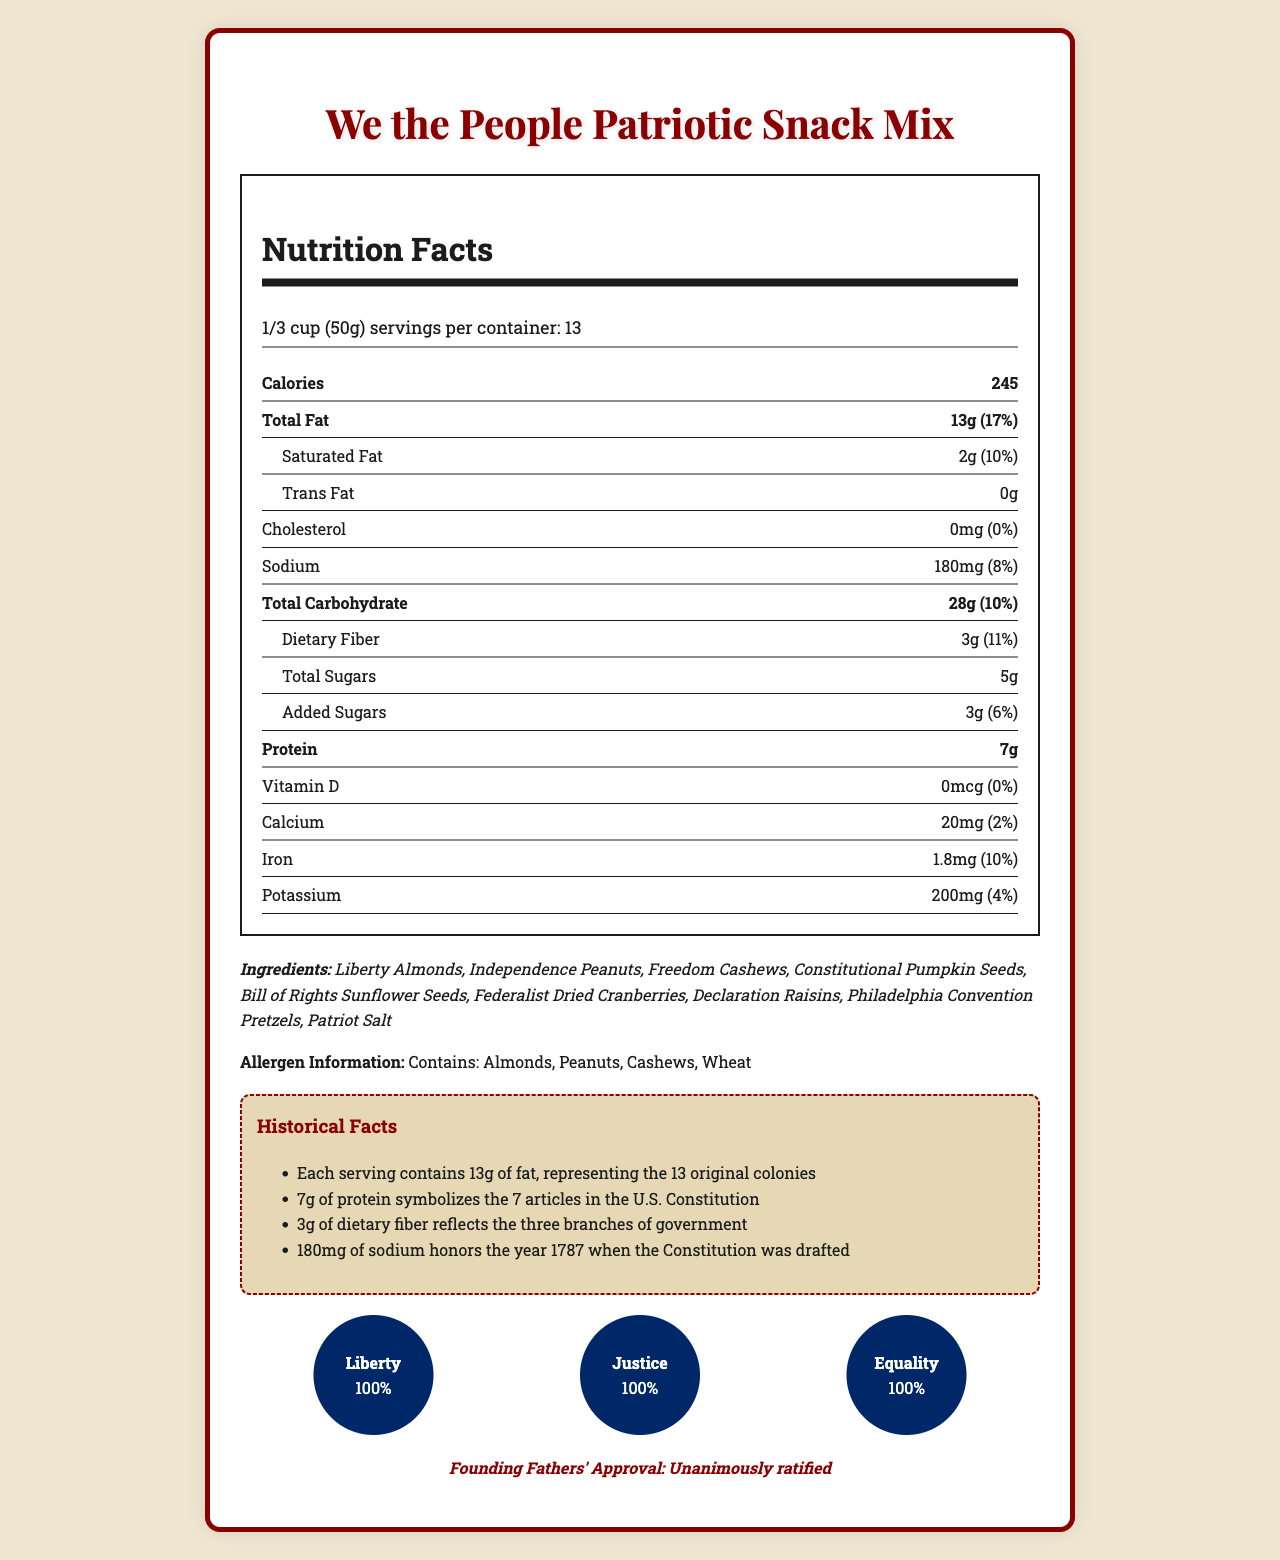what is the serving size? The serving size is explicitly mentioned near the top of the nutrition facts label.
Answer: 1/3 cup (50g) how many calories are in one serving? The label lists 245 calories per serving.
Answer: 245 what percentage of the daily value of total fat does one serving contain? The total fat amount is given as 13g and 17% of the daily value.
Answer: 17% how much protein is in one serving? The protein content per serving is listed as 7g.
Answer: 7g what is the allergen information for the snack mix? The allergen information is provided at the bottom of the label.
Answer: Contains: Almonds, Peanuts, Cashews, Wheat how many servings are in the container? The servings per container are listed as 13.
Answer: 13 how much dietary fiber is in one serving? The dietary fiber content per serving is given as 3g.
Answer: 3g how much cholesterol is in the snack mix? The label states that the cholesterol content is 0mg.
Answer: 0mg how many grams of added sugars does one serving have? The added sugars content per serving is listed as 3g.
Answer: 3g who approved the snack mix? A. Congress B. Founding Fathers C. Constitutional Convention D. Supreme Court According to the document, the snack mix is "Unanimously ratified" by the Founding Fathers.
Answer: B. Founding Fathers what is represented by 7g of protein? A. 7 Presidents B. 7 Articles C. 7 States D. 7 Amendments The document mentions that 7g of protein symbolizes the 7 articles in the U.S. Constitution.
Answer: B. 7 Articles does the snack mix contain any trans fat? The document states there are 0g of trans fat.
Answer: No summarize the main idea of the document. The nutrition facts label is designed to not only inform about the nutritional value of the snack but also to draw connections to American historical and patriotic themes, illustrated through symbolic elements and historical facts.
Answer: The document provides a nutrition facts label for the "We the People Patriotic Snack Mix," detailing its serving size, calorie content, macro and micronutrients, ingredients, allergen information, historical facts connecting nutritional values to American ideals, and founding fathers' approval. what year is honored by 180mg of sodium? The document states that 180mg of sodium honors the year 1787 when the U.S. Constitution was drafted.
Answer: 1787 how many grams of saturated fat are in each serving? The saturated fat content per serving is listed as 2g.
Answer: 2g what do the ingredients 'Freedom Cashews' and 'Bill of Rights Sunflower Seeds' represent? There is not enough information in the document to determine the exact representation of 'Freedom Cashews' and 'Bill of Rights Sunflower Seeds.'
Answer: Cannot be determined what is the value of Liberty in the patriotic values section? The document lists Liberty as having a value of 100% in the patriotic values section.
Answer: 100% what is the daily value percentage of calcium in one serving? The daily value percentage for calcium is listed as 2%.
Answer: 2% what is the primary theme of the ingredient names? The ingredient names like Liberty Almonds, Independence Peanuts, and Constitutional Pumpkin Seeds reflect patriotic and historical American ideals.
Answer: Patriotic and historical American themes 